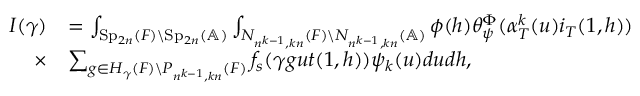Convert formula to latex. <formula><loc_0><loc_0><loc_500><loc_500>\begin{array} { r l } { I ( \gamma ) } & { = \int _ { S p _ { 2 n } ( F ) \ S p _ { 2 n } ( \mathbb { A } ) } \int _ { N _ { n ^ { k - 1 } , k n } ( F ) \ N _ { n ^ { k - 1 } , k n } ( \mathbb { A } ) } \phi ( h ) \theta _ { \psi } ^ { \Phi } ( \alpha _ { T } ^ { k } ( u ) i _ { T } ( 1 , h ) ) } \\ { \times } & { \sum _ { g \in H _ { \gamma } ( F ) \ P _ { n ^ { k - 1 } , k n } ( F ) } f _ { s } ( \gamma g u t ( 1 , h ) ) \psi _ { k } ( u ) d u d h , } \end{array}</formula> 